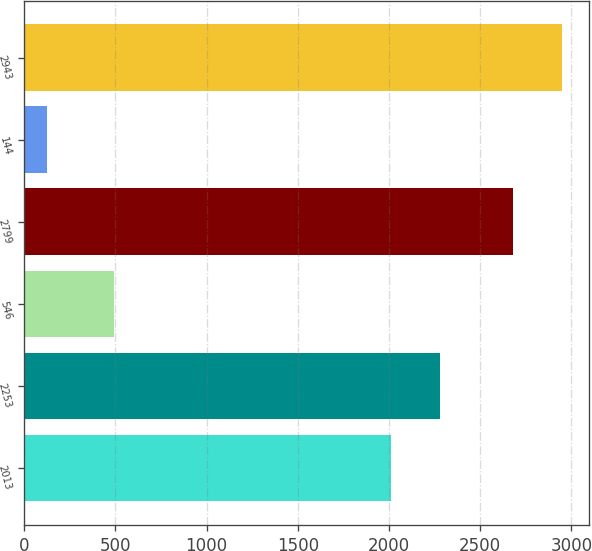Convert chart to OTSL. <chart><loc_0><loc_0><loc_500><loc_500><bar_chart><fcel>2013<fcel>2253<fcel>546<fcel>2799<fcel>144<fcel>2943<nl><fcel>2012<fcel>2280.2<fcel>493<fcel>2682<fcel>125<fcel>2950.2<nl></chart> 